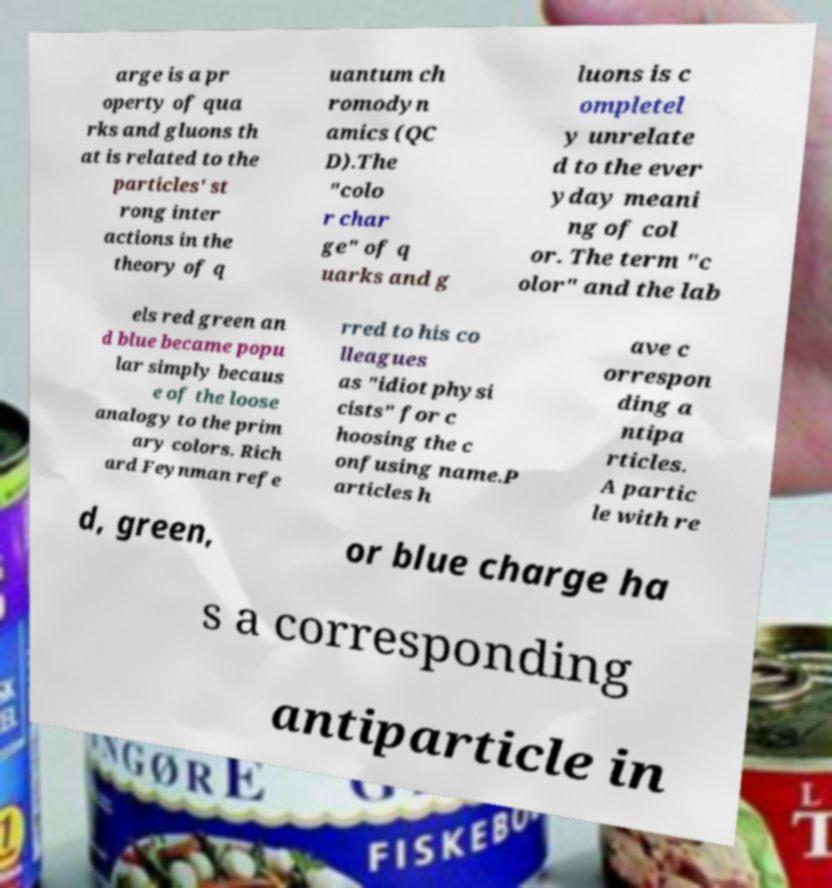What messages or text are displayed in this image? I need them in a readable, typed format. arge is a pr operty of qua rks and gluons th at is related to the particles' st rong inter actions in the theory of q uantum ch romodyn amics (QC D).The "colo r char ge" of q uarks and g luons is c ompletel y unrelate d to the ever yday meani ng of col or. The term "c olor" and the lab els red green an d blue became popu lar simply becaus e of the loose analogy to the prim ary colors. Rich ard Feynman refe rred to his co lleagues as "idiot physi cists" for c hoosing the c onfusing name.P articles h ave c orrespon ding a ntipa rticles. A partic le with re d, green, or blue charge ha s a corresponding antiparticle in 